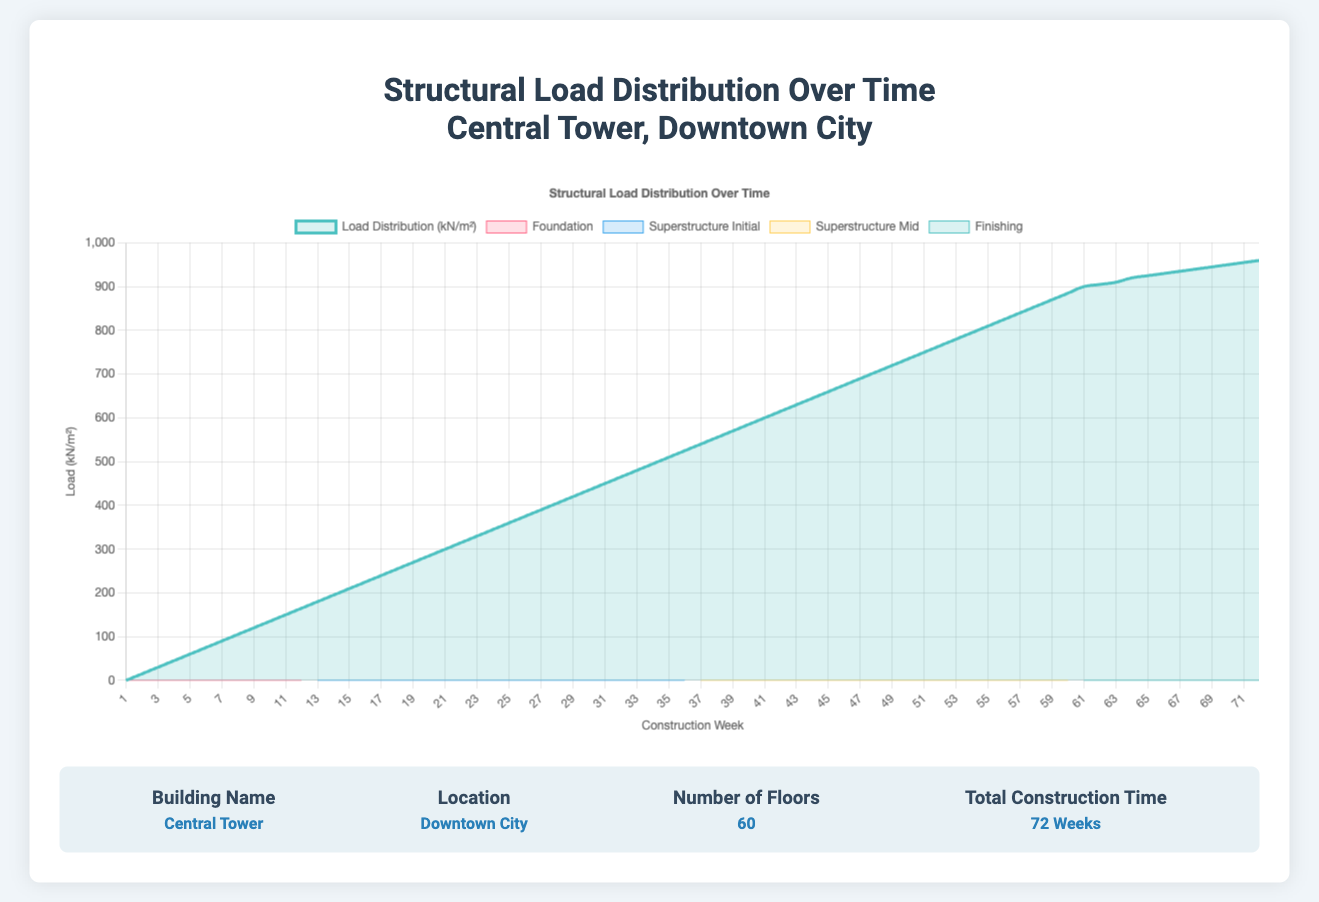What's the total structural load at the end of the Superstructure Mid stage? To find the total load at the end of the Superstructure Mid stage, look at the loadKN_per_sqm value for week 60, which is the last week of this stage. According to the data, the load at week 60 is 885 kN/m².
Answer: 885 kN/m² Between which periods do you see the fastest increase in load? The fastest increase in load can be identified by observing the steepness of the curve in each stage. The Foundation and the Superstructure Initial stages show linear increases, but the Superstructure Initial stage shows a steeper slope, indicating a faster increase in load. Specifically, from week 12 to 36 the load increases by 15 kN/m² each week.
Answer: Weeks 12 to 36 Compare the load during the initial week of the Finishing stage to the final week of the Foundation stage. In the initial week of the Finishing stage (week 61), the load is 900 kN/m², while the load in the final week of the Foundation stage (week 12) is 165 kN/m². To compare, note the difference which is 900 - 165 = 735 kN/m².
Answer: 735 kN/m² higher in the Finishing stage What is the average weekly load increase during the Foundation stage? To find the average weekly load increase during the Foundation stage, note that the load increases from 0 kN/m² to 165 kN/m² over 12 weeks. Average increase per week = (165 - 0) kN/m² / 12 weeks = 165 / 12 = 13.75 kN/m²
Answer: 13.75 kN/m² Which stage witnesses the smallest weekly load increase? By examining the curve's slopes, the Finishing stage exhibits the smallest weekly increase. It increases by 60 kN/m² over 12 weeks, which equates to 60 / 12 = 5 kN/m² each week.
Answer: Finishing What's the overall structural load difference between the start and end of the Superstructure Initial stage? The load at the start (week 12) is 165 kN/m², and at the end (week 36) it is 525 kN/m². The difference = 525 - 165 = 360 kN/m².
Answer: 360 kN/m² How does the load at week 30 compare visually to week 45? From the plotted curve, at week 30 the load is 435 kN/m² whereas at week 45 it is 660 kN/m². Visually, the point at week 45 appears significantly higher than the point at week 30.
Answer: Higher at week 45 What is the total construction time shown in the figure? The total construction time can be determined by summing up the time frames of all the stages. Foundation (12 weeks) + Superstructure Initial (24 weeks) + Superstructure Mid (24 weeks) + Finishing (12 weeks) = 12 + 24 + 24 + 12 = 72 weeks.
Answer: 72 weeks Calculate the cumulative load increase from week 1 to week 24. The cumulative load increase from week 1 (0 kN/m²) to week 24 (345 kN/m²) can be found by subtracting the initial load from the final load: 345 - 0 = 345 kN/m².
Answer: 345 kN/m² 